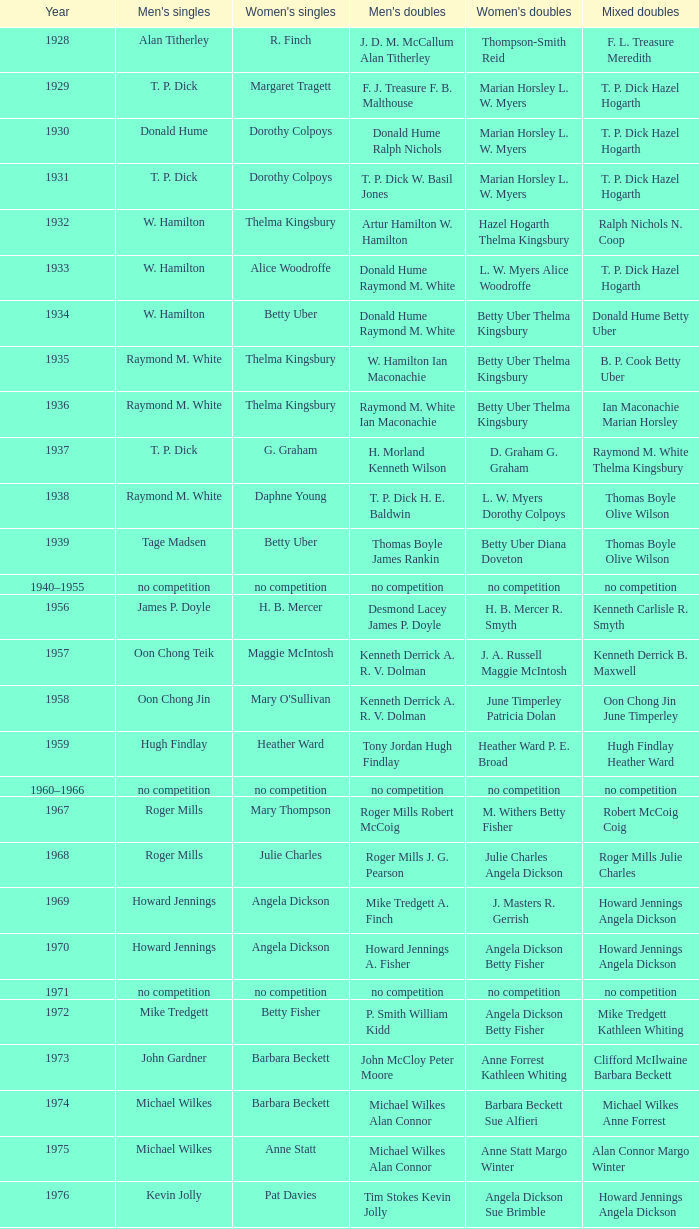Who won the Women's doubles in the year that Jesper Knudsen Nettie Nielsen won the Mixed doubles? Karen Beckman Sara Halsall. 